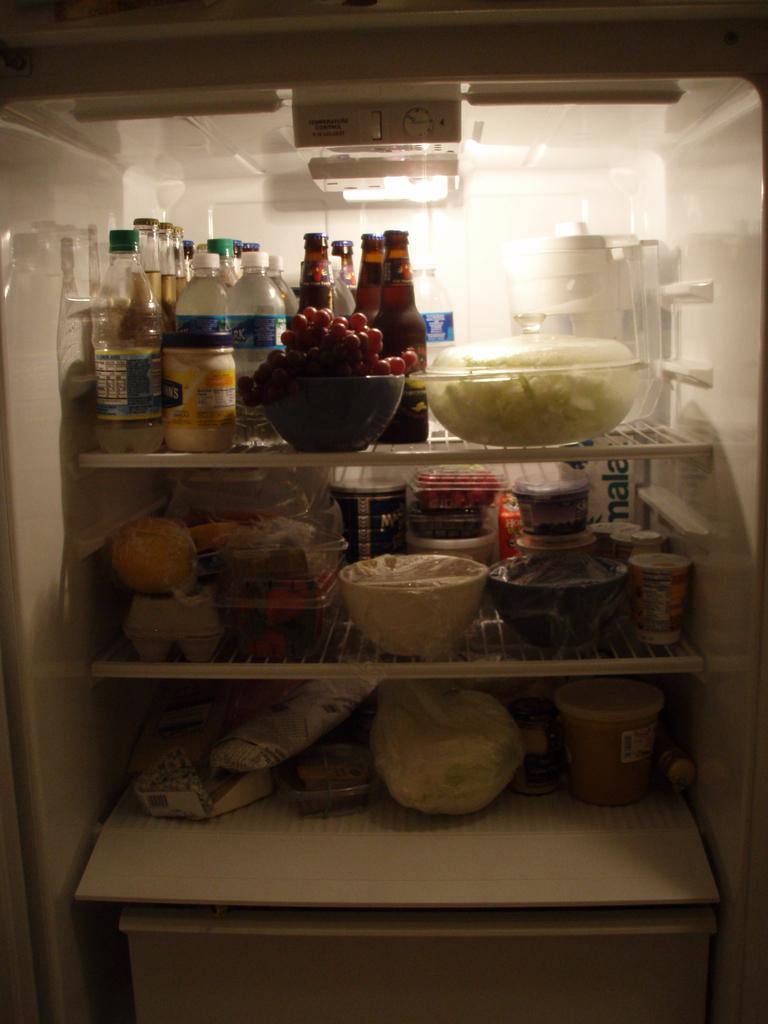What word is written on the bottle on the middle right shelf of the fridge?
Provide a succinct answer. Mala. What is the last letter written in white on the white condiment jar?
Your answer should be very brief. S. 